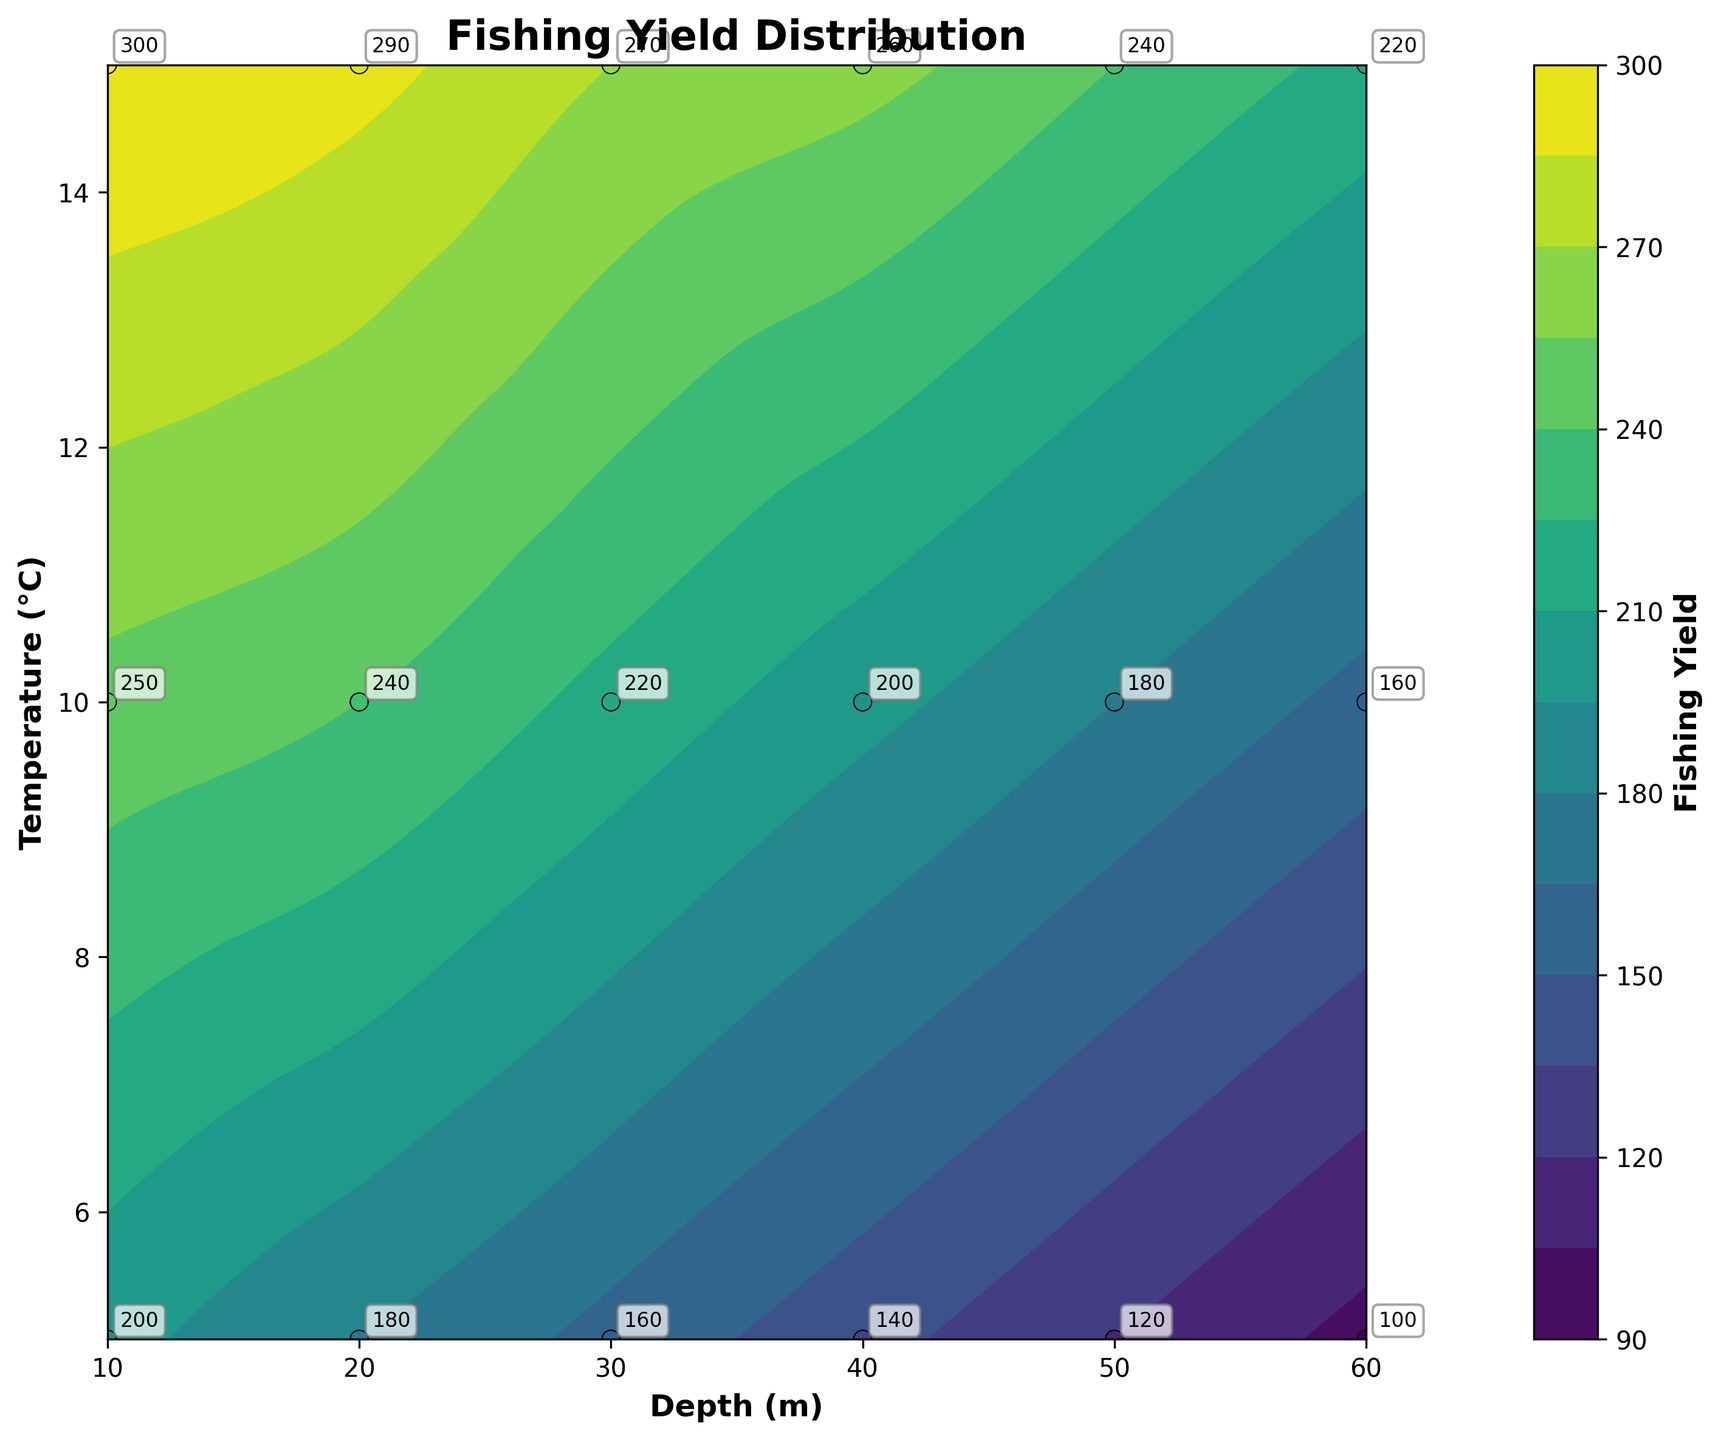What is the title of the figure? Look for the text provided at the top of the plot.
Answer: Fishing Yield Distribution What are the labels on the x-axis and y-axis? Identify the text provided along the horizontal and vertical axes.
Answer: Depth (m) and Temperature (°C) What is the range of the fishing yield depicted in the plot? Check the values on the colorbar to determine the minimum and maximum fishing yields.
Answer: 100-300 Which depth has the highest fishing yield at 10°C? To find this, locate 10°C on the y-axis and find the depth where the fishing yield is highest, based on the color and annotations.
Answer: 10 m At which temperature does the maximum fishing yield occur at a depth of 30 meters? Locate 30 m on the x-axis, then identify the temperature where the fishing yield is maximum, referring to the darkest color or the highest annotation value.
Answer: 15°C How does the fishing yield change as depth increases from 10 m to 60 m at 5°C? Observe the contour lines and data points at 5°C on the y-axis and trace how the fishing yield values change as you move from 10 m to 60 m.
Answer: It decreases What is the average fishing yield at a depth of 20 m? Identify the fishing yield values for all temperatures at 20 m, then calculate the average. (180 + 240 + 290)/3 = 710/3 = 236.67
Answer: 236.67 Compare the fishing yields at 10 m and 50 m depths for the temperature of 15°C. Look at the fishing yield values annotated at 15°C for both 10 m and 50 m depths and compare them.
Answer: 300 at 10 m, 240 at 50 m Which combination of depth and temperature yields the minimum fishing yield? Locate the smallest value in the annotations or the color gradient and identify the corresponding depth and temperature.
Answer: 60 m, 5°C At which depth-temperature combination does the fishing yield exceed 250? Find points on the plot where the fishing yield is greater than 250, using the color and annotations, and note the corresponding depth and temperature values.
Answer: 10 m at 10°C and 15°C; 20 m at 15°C; 30 m at 15°C 